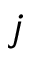<formula> <loc_0><loc_0><loc_500><loc_500>j</formula> 